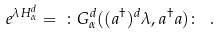Convert formula to latex. <formula><loc_0><loc_0><loc_500><loc_500>e ^ { \lambda H _ { \alpha } ^ { d } } = \ \colon G _ { \alpha } ^ { d } ( ( a ^ { \dag } ) ^ { d } \lambda , a ^ { \dag } a ) \colon \ .</formula> 